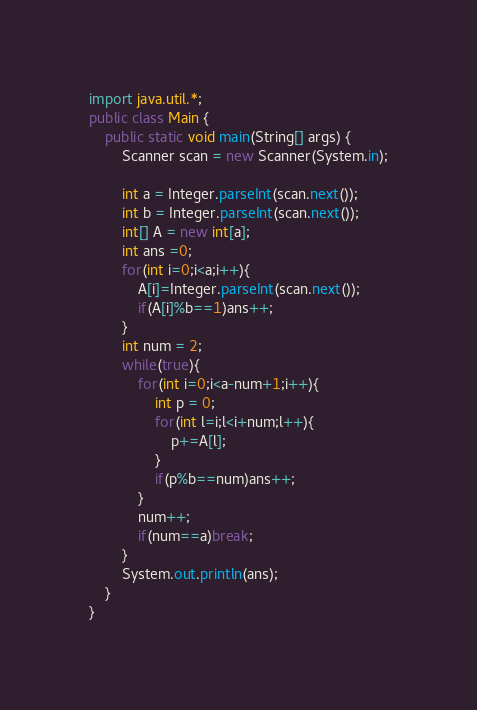Convert code to text. <code><loc_0><loc_0><loc_500><loc_500><_Java_>import java.util.*;
public class Main {
    public static void main(String[] args) {
        Scanner scan = new Scanner(System.in);

        int a = Integer.parseInt(scan.next());
        int b = Integer.parseInt(scan.next());
        int[] A = new int[a];
        int ans =0;
        for(int i=0;i<a;i++){
            A[i]=Integer.parseInt(scan.next());
            if(A[i]%b==1)ans++;
        }
        int num = 2;
        while(true){
            for(int i=0;i<a-num+1;i++){
                int p = 0;
                for(int l=i;l<i+num;l++){
                    p+=A[l];
                }
                if(p%b==num)ans++;
            }
            num++;
            if(num==a)break;
        }
        System.out.println(ans);
    }
}
</code> 